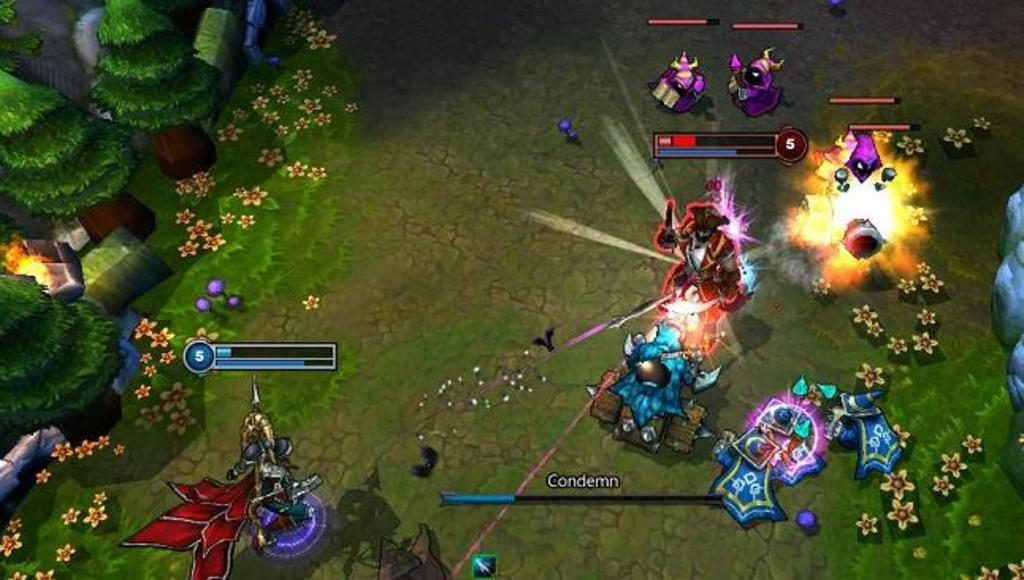What type of image is this? The image is animated. What can be seen on the left side of the image? There are trees, flowers, and fire on the left side of the image. What is present at the bottom of the image? There is some text at the bottom of the image. What type of toy can be seen playing with the letters in the image? There is no toy or letters present in the image. 